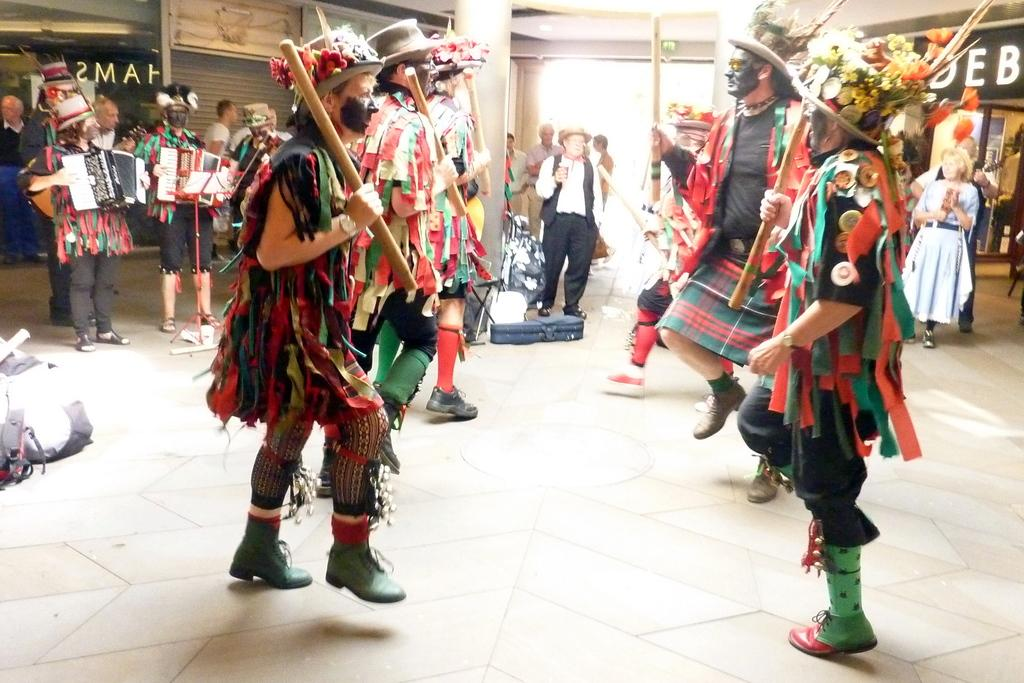How many people are in the image? There are people in the image, but the exact number is not specified. What are some of the people wearing? Some of the people are wearing different costumes. What are the other people holding in the image? There are other people holding things in the image, but the specific items are not mentioned. What type of bean is being used as a prop by the people in the image? There is no bean present in the image; the people are wearing costumes and holding other things, but no beans are mentioned. 